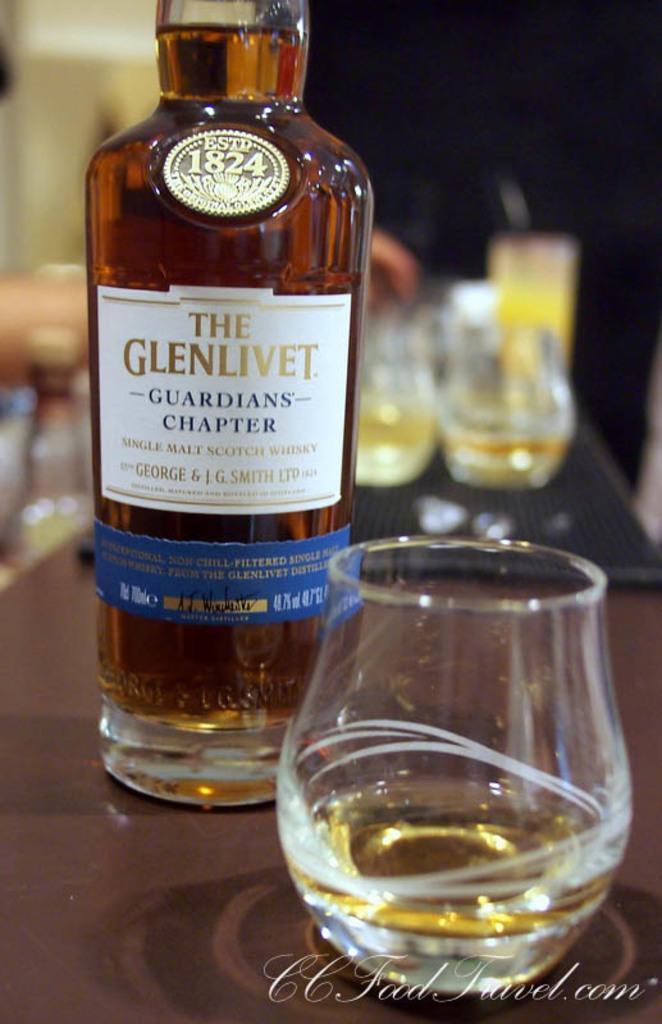<image>
Relay a brief, clear account of the picture shown. A bottle of The Glenlivet guarians chapter whiskey sits next to a glass. 